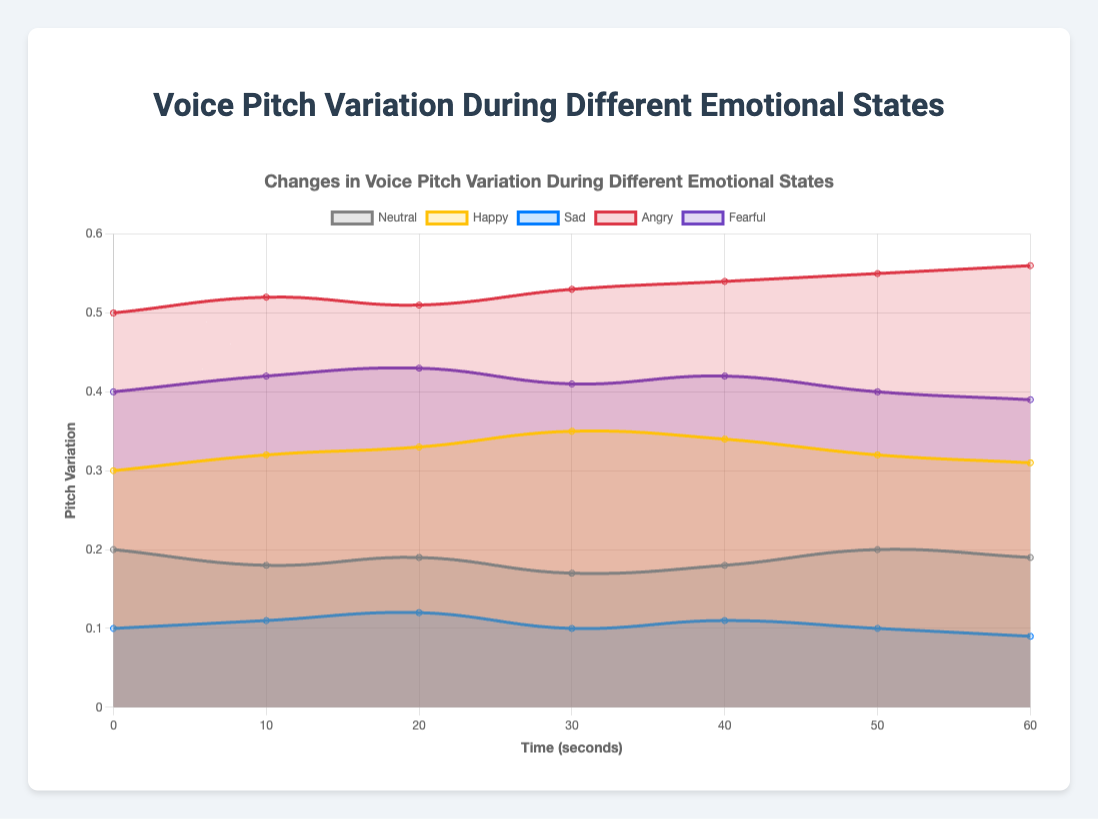What is the title of the chart? The title of the chart can be found at the top of the figure, it is clearly labeled.
Answer: Voice Pitch Variation During Different Emotional States How many emotional states are represented in the chart? Each emotional state is represented by a different color and labeled in the chart legend. Count the number of different emotions listed there.
Answer: 5 What color represents the "Angry" emotional state? The color corresponding to the "Angry" emotional state can be identified by looking at the legend. The legend links the emotions to their respective colors.
Answer: Red Which emotional state shows the highest pitch variation over the 60 seconds? To identify the highest pitch variation, compare the values on the y-axis for each emotional state across the 60-second duration.
Answer: Angry What is the average pitch variation for the "Neutral" emotional state? Calculate the average by summing up all the pitch variation values for "Neutral" and dividing by the number of data points: (0.2 + 0.18 + 0.19 + 0.17 + 0.18 + 0.2 + 0.19) / 7.
Answer: 0.187 How does the pitch variation for "Sad" at 30 seconds compare to that of "Happy" at the same point in time? Locate the 30-second mark on the x-axis and compare the pitch variation values for "Sad" and "Happy" at this point. "Sad" has a pitch variation of 0.10 and "Happy" has a pitch variation of 0.35.
Answer: "Happy" is higher At which time point does "Fearful" have its lowest pitch variation? Identify the point on the x-axis where the pitch variation for "Fearful" is the lowest by checking the data points for the "Fearful" curve.
Answer: 60 seconds How does the pitch variation trend for "Happy" change from 20 seconds to 40 seconds? Examine the pitch variation values for "Happy" from 20 seconds to 40 seconds: 0.33 at 20s, 0.35 at 30s, and 0.34 at 40s. It increases slightly up to 30s and then decreases slightly by 40s.
Answer: Increases then decreases Which emotional state exhibits the most stable pitch variation over the time period? The most stable pitch variation can be identified by looking for the emotional state with the least fluctuation in its pitch variation values. "Neutral" stays relatively stable compared to others.
Answer: Neutral What is the pitch variation difference between "Angry" and "Sad" at the 50-second mark? To find the difference, subtract the pitch variation value for "Sad" at 50s (0.10) from that of "Angry" at 50s (0.55): 0.55 - 0.10.
Answer: 0.45 